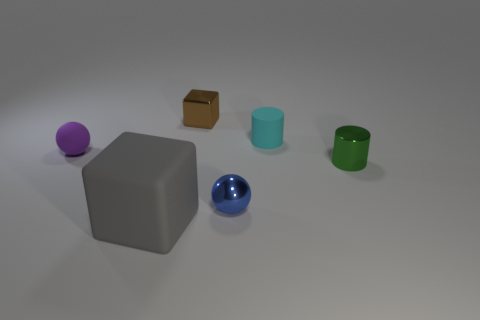Add 2 gray cubes. How many objects exist? 8 Add 4 large blue blocks. How many large blue blocks exist? 4 Subtract 0 blue cylinders. How many objects are left? 6 Subtract all cylinders. How many objects are left? 4 Subtract all blue spheres. Subtract all purple cylinders. How many spheres are left? 1 Subtract all purple metal blocks. Subtract all blue shiny spheres. How many objects are left? 5 Add 4 small cubes. How many small cubes are left? 5 